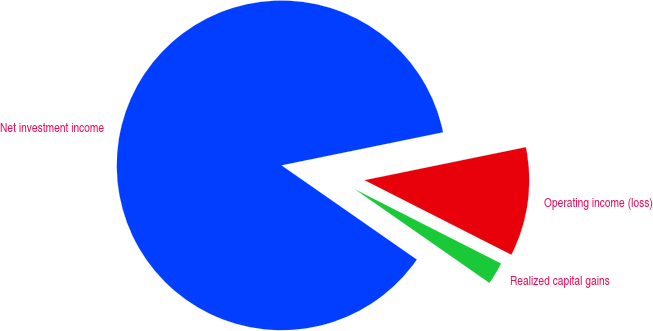Convert chart to OTSL. <chart><loc_0><loc_0><loc_500><loc_500><pie_chart><fcel>Net investment income<fcel>Realized capital gains<fcel>Operating income (loss)<nl><fcel>87.1%<fcel>2.2%<fcel>10.69%<nl></chart> 